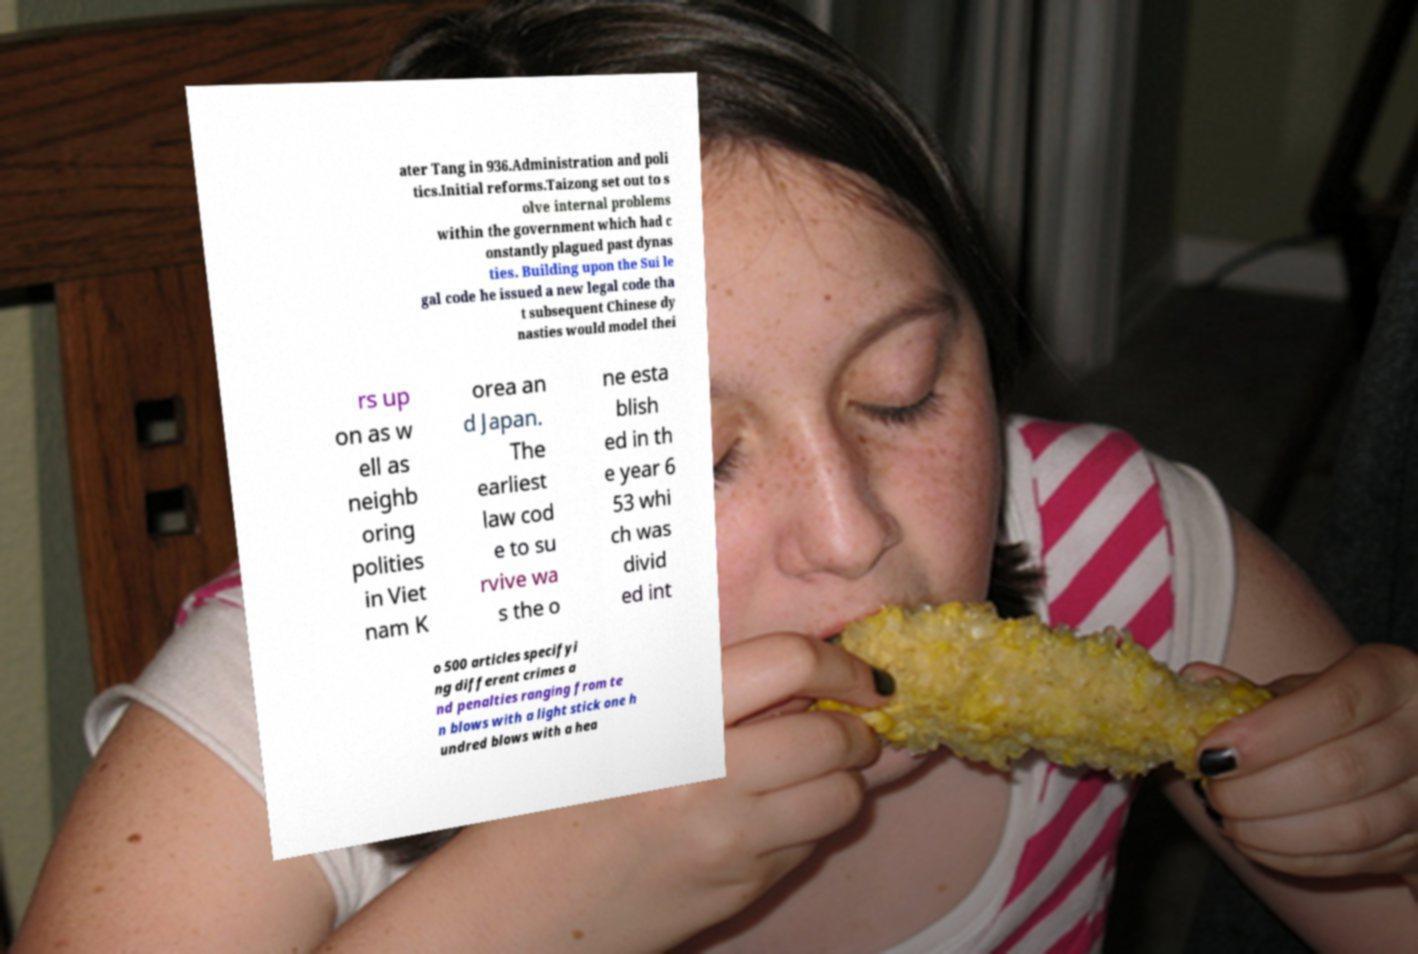For documentation purposes, I need the text within this image transcribed. Could you provide that? ater Tang in 936.Administration and poli tics.Initial reforms.Taizong set out to s olve internal problems within the government which had c onstantly plagued past dynas ties. Building upon the Sui le gal code he issued a new legal code tha t subsequent Chinese dy nasties would model thei rs up on as w ell as neighb oring polities in Viet nam K orea an d Japan. The earliest law cod e to su rvive wa s the o ne esta blish ed in th e year 6 53 whi ch was divid ed int o 500 articles specifyi ng different crimes a nd penalties ranging from te n blows with a light stick one h undred blows with a hea 